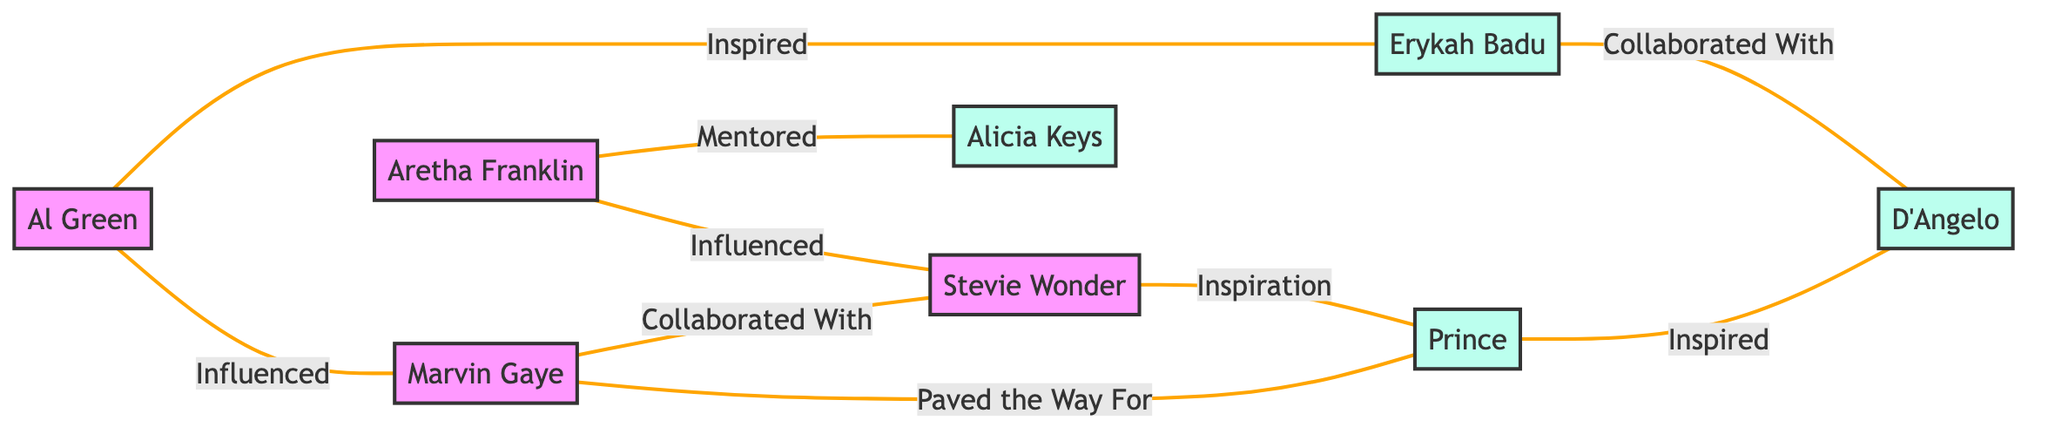What's the total number of nodes in the graph? There are 8 nodes in the graph, namely Marvin Gaye, Stevie Wonder, Aretha Franklin, Al Green, Prince, D'Angelo, Erykah Badu, and Alicia Keys.
Answer: 8 How many edges connect Marvin Gaye? Marvin Gaye is connected by 3 edges: to Stevie Wonder (Collaborated With), to Al Green (Influenced), and to Prince (Paved the Way For).
Answer: 3 Who influenced Stevie Wonder? Aretha Franklin is noted as influencing Stevie Wonder, as indicated by the connection labeled "Influenced."
Answer: Aretha Franklin What relationship exists between Al Green and Marvin Gaye? The relationship between Al Green and Marvin Gaye is indicated as "Influenced," showing that Al Green had an impact on Marvin Gaye's music.
Answer: Influenced Which artist did Aretha Franklin mentor? Aretha Franklin mentored Alicia Keys, as shown by the connection labeled "Mentored."
Answer: Alicia Keys Which modern artist is inspired by Prince? D'Angelo is the modern artist inspired by Prince, as indicated by the relationship labeled "Inspired."
Answer: D'Angelo How many total unique relationships are represented in the graph? There are 8 unique relationships represented in the graph, each indicating a different type of influence or collaboration between the artists.
Answer: 8 What type of connection exists between Erykah Badu and D'Angelo? The connection between Erykah Badu and D'Angelo is labeled "Collaborated With," indicating a collaborative relationship between them.
Answer: Collaborated With Which artist is described as an inspiration source for multiple others? Stevie Wonder is described as an inspiration source for both Prince and through him, D'Angelo, showing his broad influence in the network.
Answer: Stevie Wonder 